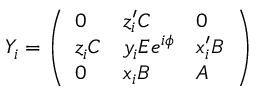<formula> <loc_0><loc_0><loc_500><loc_500>Y _ { i } = \left ( \begin{array} { l l l } { 0 } & { { z _ { i } ^ { \prime } C } } & { 0 } \\ { { z _ { i } C } } & { { y _ { i } E e ^ { i \phi } } } & { { x _ { i } ^ { \prime } B } } \\ { 0 } & { { x _ { i } B } } & { A } \end{array} \right )</formula> 